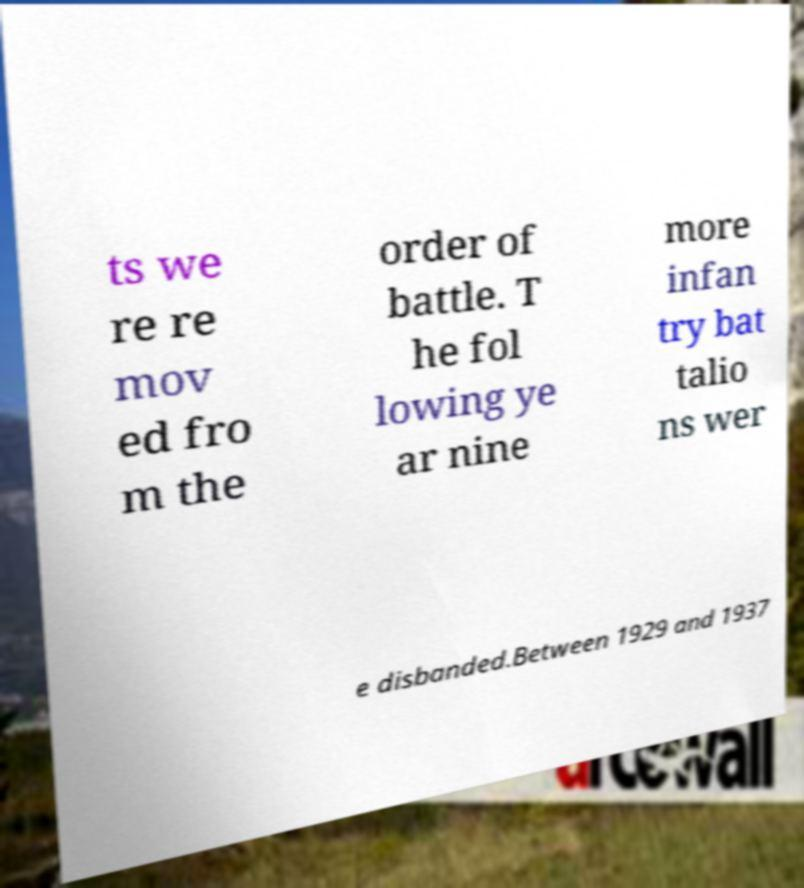What messages or text are displayed in this image? I need them in a readable, typed format. ts we re re mov ed fro m the order of battle. T he fol lowing ye ar nine more infan try bat talio ns wer e disbanded.Between 1929 and 1937 